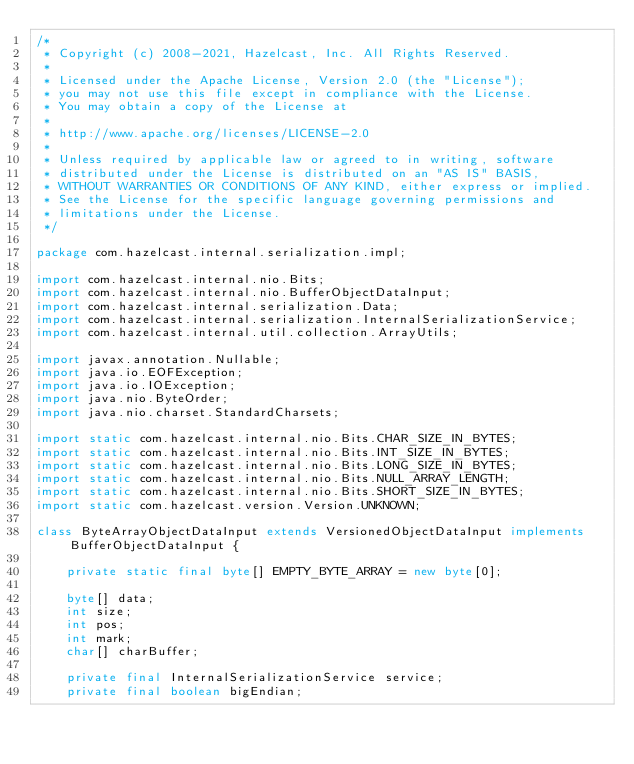<code> <loc_0><loc_0><loc_500><loc_500><_Java_>/*
 * Copyright (c) 2008-2021, Hazelcast, Inc. All Rights Reserved.
 *
 * Licensed under the Apache License, Version 2.0 (the "License");
 * you may not use this file except in compliance with the License.
 * You may obtain a copy of the License at
 *
 * http://www.apache.org/licenses/LICENSE-2.0
 *
 * Unless required by applicable law or agreed to in writing, software
 * distributed under the License is distributed on an "AS IS" BASIS,
 * WITHOUT WARRANTIES OR CONDITIONS OF ANY KIND, either express or implied.
 * See the License for the specific language governing permissions and
 * limitations under the License.
 */

package com.hazelcast.internal.serialization.impl;

import com.hazelcast.internal.nio.Bits;
import com.hazelcast.internal.nio.BufferObjectDataInput;
import com.hazelcast.internal.serialization.Data;
import com.hazelcast.internal.serialization.InternalSerializationService;
import com.hazelcast.internal.util.collection.ArrayUtils;

import javax.annotation.Nullable;
import java.io.EOFException;
import java.io.IOException;
import java.nio.ByteOrder;
import java.nio.charset.StandardCharsets;

import static com.hazelcast.internal.nio.Bits.CHAR_SIZE_IN_BYTES;
import static com.hazelcast.internal.nio.Bits.INT_SIZE_IN_BYTES;
import static com.hazelcast.internal.nio.Bits.LONG_SIZE_IN_BYTES;
import static com.hazelcast.internal.nio.Bits.NULL_ARRAY_LENGTH;
import static com.hazelcast.internal.nio.Bits.SHORT_SIZE_IN_BYTES;
import static com.hazelcast.version.Version.UNKNOWN;

class ByteArrayObjectDataInput extends VersionedObjectDataInput implements BufferObjectDataInput {

    private static final byte[] EMPTY_BYTE_ARRAY = new byte[0];

    byte[] data;
    int size;
    int pos;
    int mark;
    char[] charBuffer;

    private final InternalSerializationService service;
    private final boolean bigEndian;
</code> 